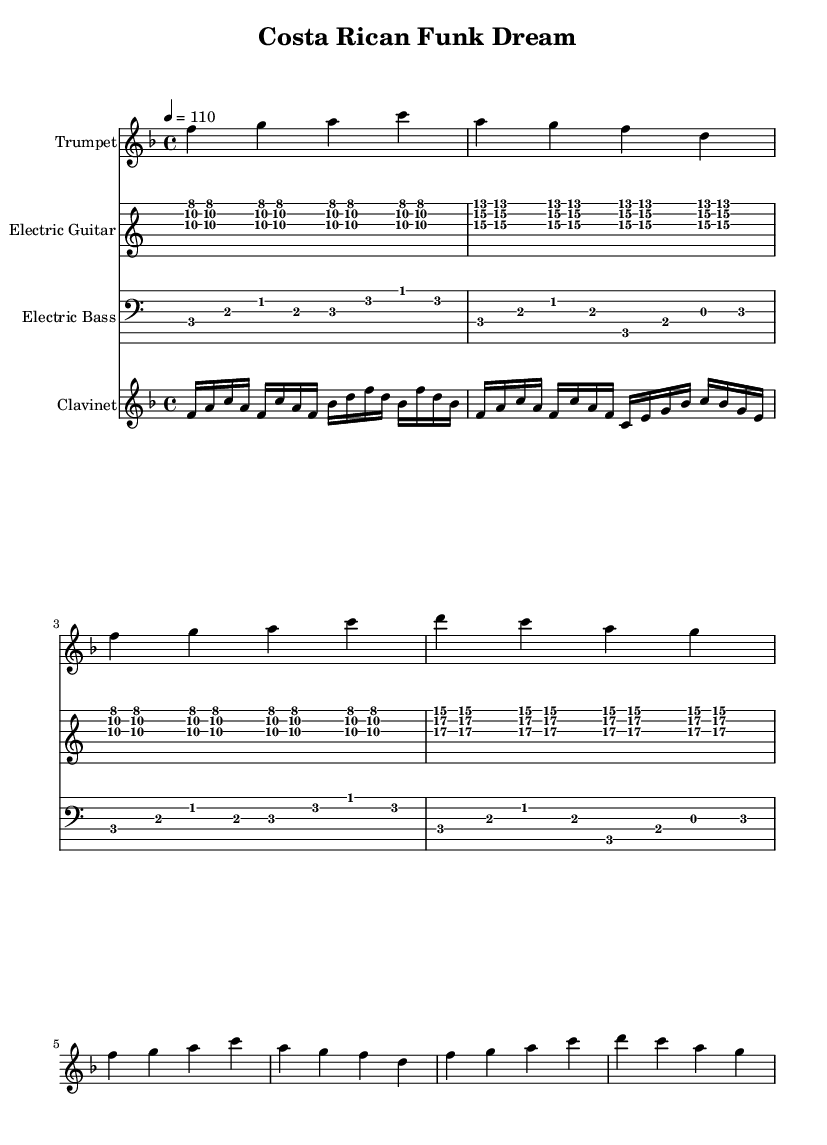What is the key signature of this music? The key signature indicated at the beginning of the staff shows one flat, which corresponds to F major.
Answer: F major What is the time signature of this music? The time signature is shown at the beginning of the score as 4/4, indicating four beats per measure.
Answer: 4/4 What is the tempo marking for this piece? The tempo marking is indicated by "4 = 110", suggesting a speed of 110 beats per minute.
Answer: 110 How many measures are present in the trumpet part? Counting the measures in the trumpet part reveals a total of 8 measures. Each measure has a consistent rhythm, confirming this count.
Answer: 8 Which instrument plays the highest pitched notes? Looking through the provided parts, the trumpet part contains the highest notes, as it is written in the treble clef and typically plays soprano lines.
Answer: Trumpet What type of chords does the electric guitar primarily use? The electric guitar part features triads, as seen in phrases with combinations of three notes sounded together, typical of funk music.
Answer: Triads What rhythmic style is predominant in the clavinet part? The clavinet section predominantly uses a syncopated rhythm, characterized by off-beat accents that create a funky feel throughout the music.
Answer: Syncopated 